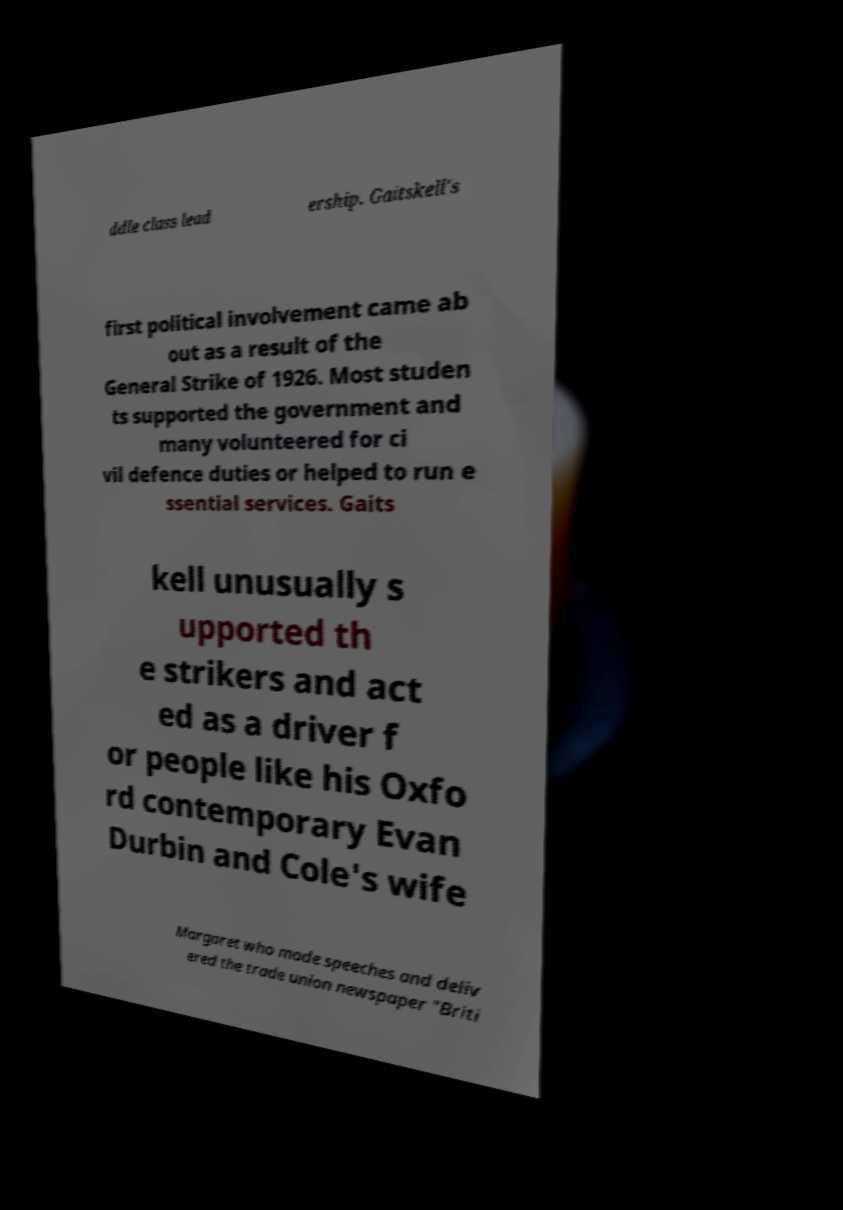Could you assist in decoding the text presented in this image and type it out clearly? ddle class lead ership. Gaitskell's first political involvement came ab out as a result of the General Strike of 1926. Most studen ts supported the government and many volunteered for ci vil defence duties or helped to run e ssential services. Gaits kell unusually s upported th e strikers and act ed as a driver f or people like his Oxfo rd contemporary Evan Durbin and Cole's wife Margaret who made speeches and deliv ered the trade union newspaper "Briti 